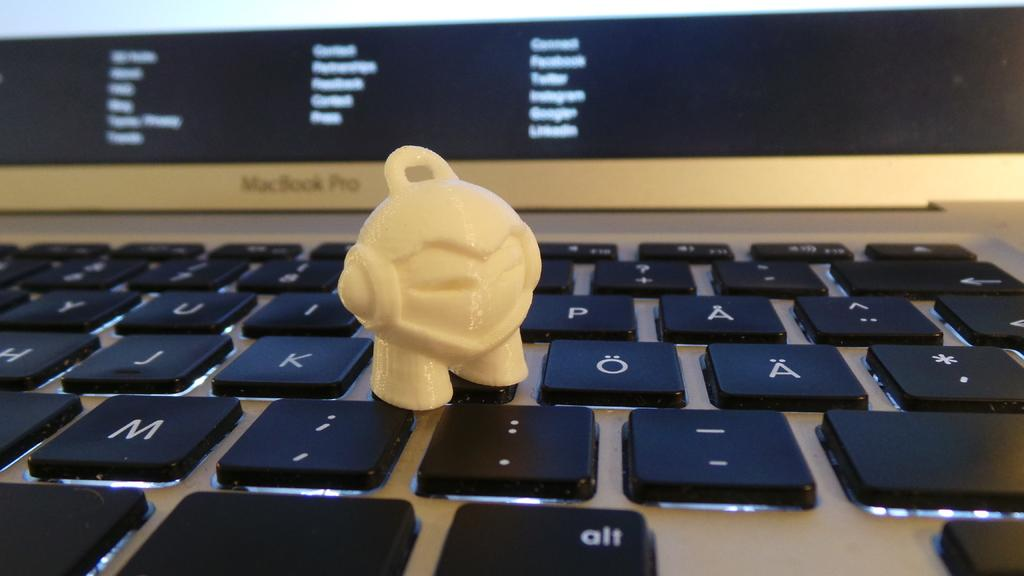Provide a one-sentence caption for the provided image. A white object stands next to the letter K on a keyboard. 